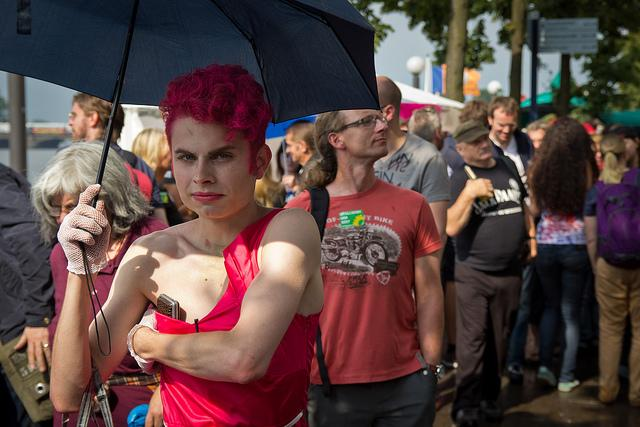Why does the man holding the umbrella have very red lips? lipstick 